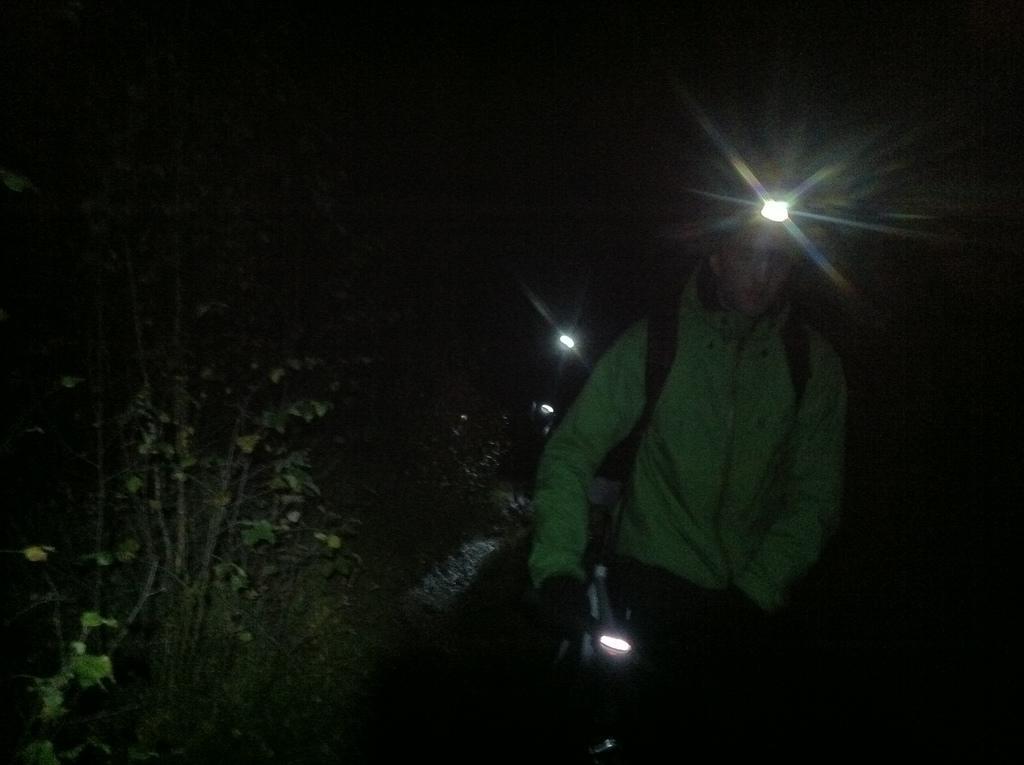Describe this image in one or two sentences. In this image there are persons walking and holding lights. On the left side there are trees. 